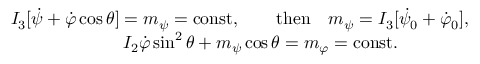Convert formula to latex. <formula><loc_0><loc_0><loc_500><loc_500>\begin{array} { r } { I _ { 3 } [ \dot { \psi } + \dot { \varphi } \cos \theta ] = m _ { \psi } = c o n s t , \quad t h e n \quad m _ { \psi } = I _ { 3 } [ \dot { \psi } _ { 0 } + \dot { \varphi } _ { 0 } ] , } \\ { I _ { 2 } \dot { \varphi } \sin ^ { 2 } \theta + m _ { \psi } \cos \theta = m _ { \varphi } = c o n s t . \quad } \end{array}</formula> 